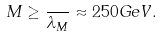<formula> <loc_0><loc_0><loc_500><loc_500>M \geq \frac { } { \lambda _ { M } } \approx 2 5 0 G e V .</formula> 